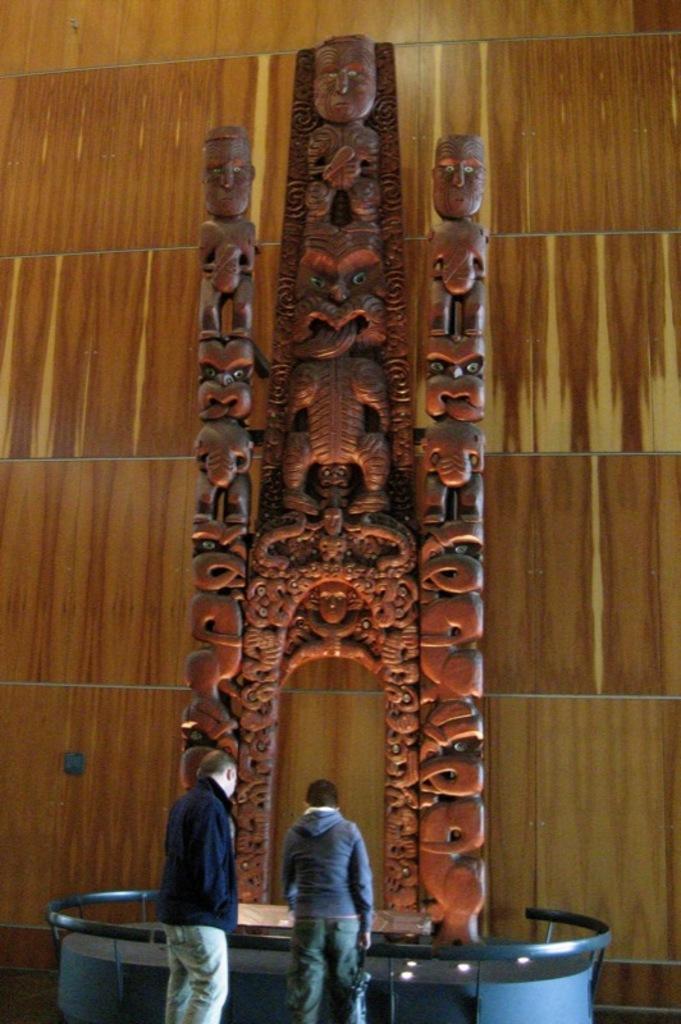In one or two sentences, can you explain what this image depicts? This image consists of two persons. They are wearing jackets. In the front, it looks like an idol. In the background, there is a wall made up of wood. At the bottom, the table is in blue color. 